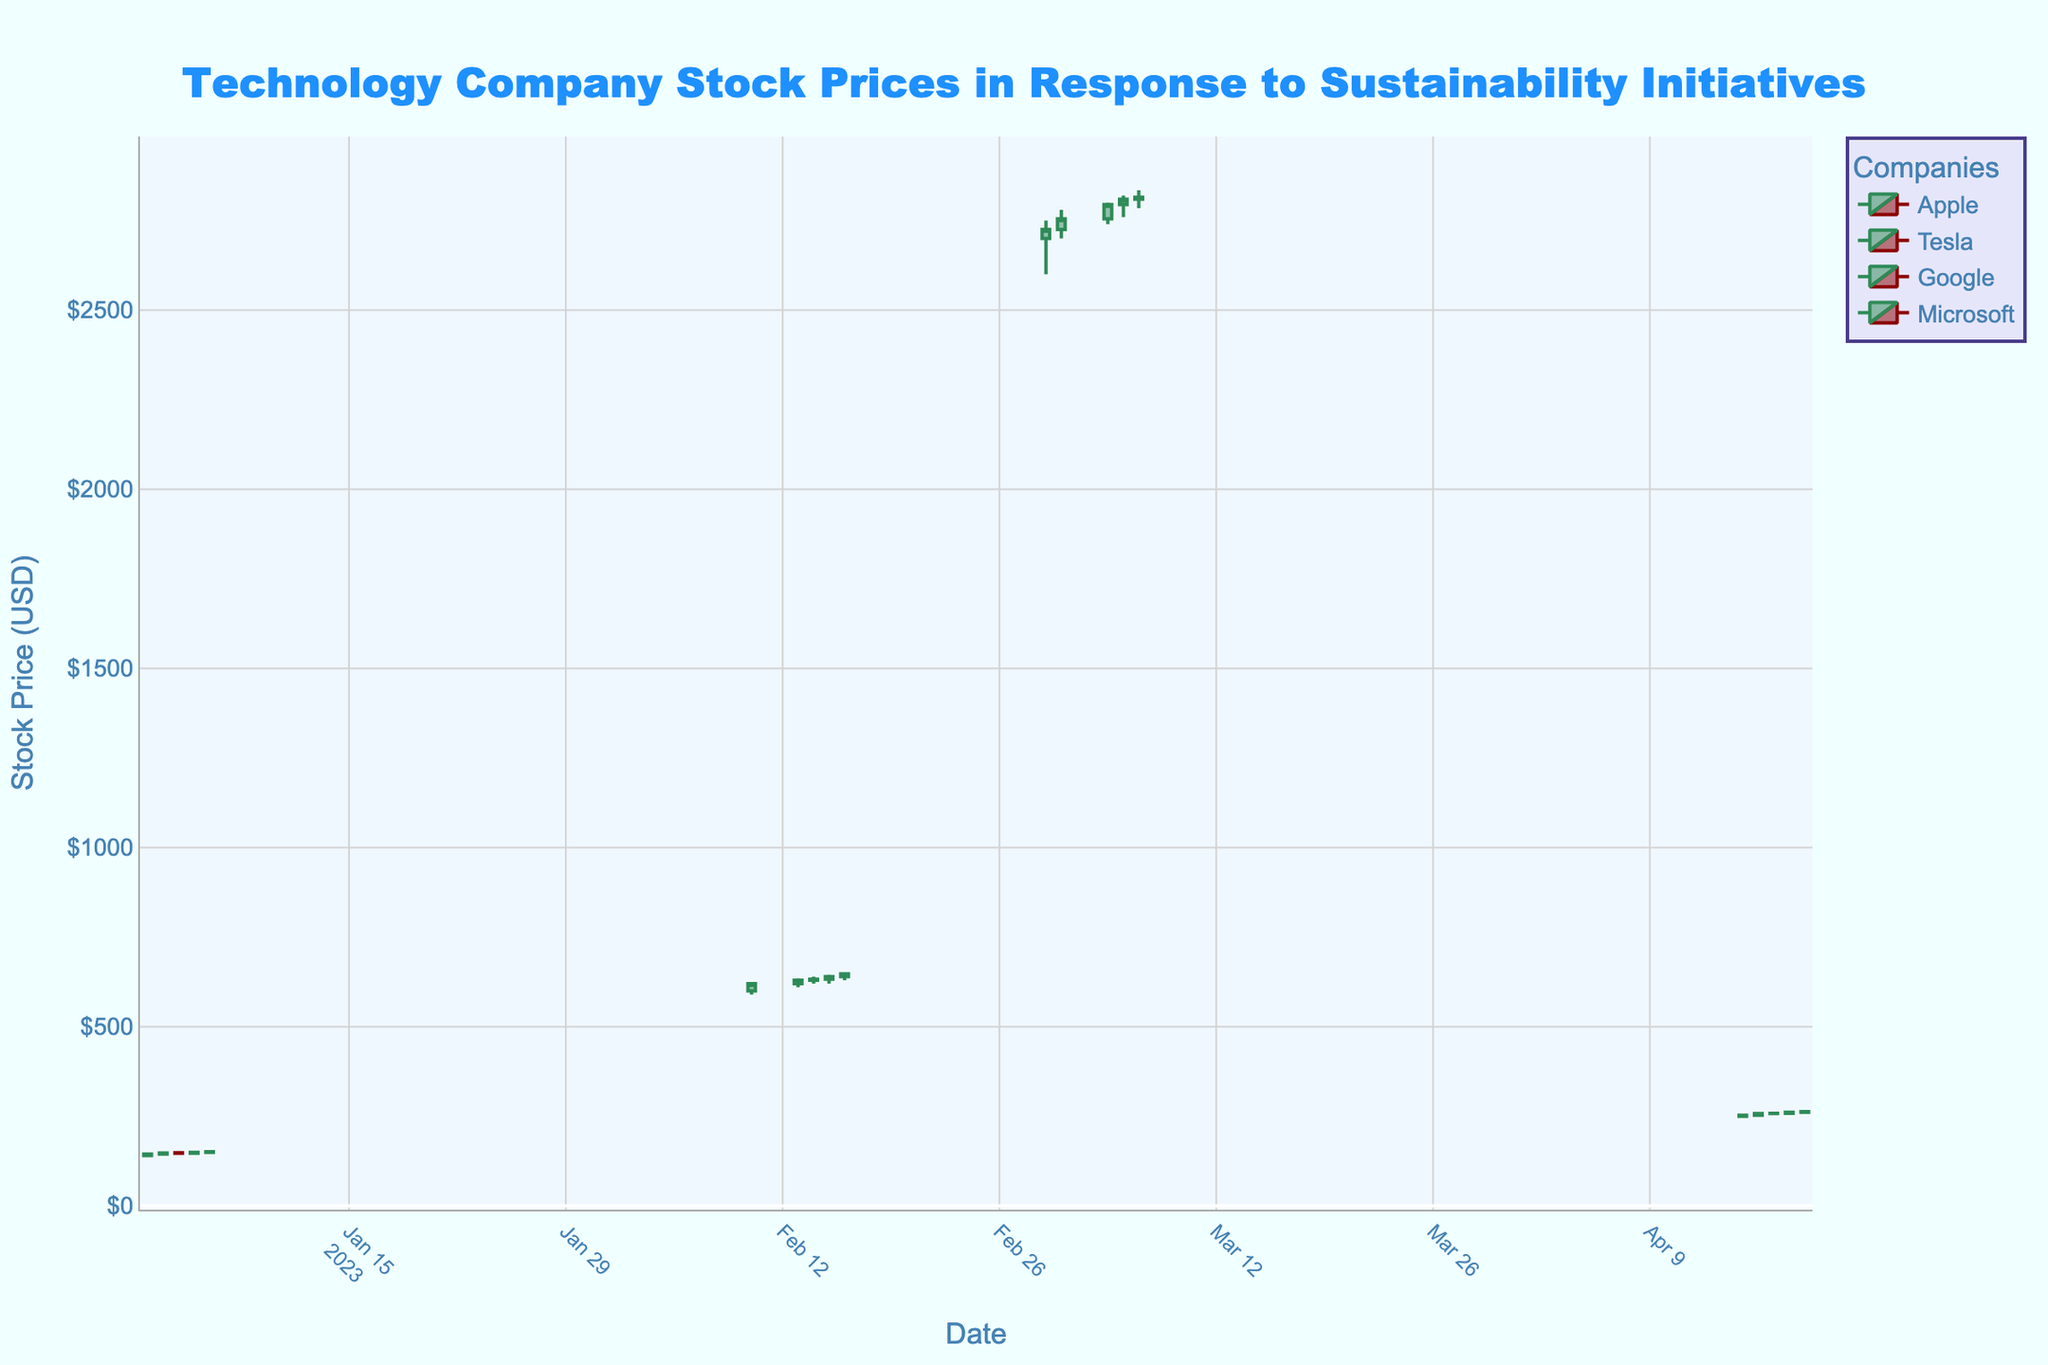What is the title of the figure? The title is displayed prominently at the top of the figure in a large font size and a blue color, making it easily noticeable.
Answer: Technology Company Stock Prices in Response to Sustainability Initiatives Which company had the highest stock price peak in the given data? To determine this, look for the highest point in the "High" markers across all candlestick plots. Tesla's highest peak was $650.00 on 2023-02-16.
Answer: Tesla On which date did Microsoft have the lowest stock price, and what was it? Look at the lowest points in the candlestick chart for Microsoft. The lowest was $245.00 on 2023-04-15.
Answer: 2023-04-15 and $245.00 How many data points are there for each company? Check the different candlestick sections for each company and count the number of dates involved. Each company has 5 data points.
Answer: 5 data points each What was the opening stock price for Apple on 2023-01-05? Identify the candlestick corresponding to 2023-01-05 for Apple and find the "Open" value. The opening price was $147.00.
Answer: $147.00 Which company's stock price increased the most in a single day and by how much? Identify the largest difference between "Low" and "High" values in a single candlestick. Tesla’s stock price increased by $35.00 on 2023-02-10, going from $590.00 to $625.00.
Answer: Tesla by $35.00 Compare the closing stock prices of Google on 2023-03-06 and 2023-03-07. Was there an increase or decrease, and by how much? Check the "Close" values for both dates and compute the difference. On 2023-03-06, it was $2810.00, and on 2023-03-07, it was $2815.00, an increase of $5.00.
Answer: Increase by $5.00 What was Tesla's average closing stock price over the given dates? Sum up all closing prices for Tesla and divide by the number of data points. ($620.00 + $630.00 + $632.50 + $640.00 + $647.50) / 5 = $634.00.
Answer: $634.00 When did Apple have its highest opening stock price and what was it? Look through the "Open" values for Apple across the dates and find the highest one. The highest opening price was $149.50 on 2023-01-06.
Answer: 2023-01-06 and $149.50 What is the general trend observed for Google's stock price from 2023-03-01 to 2023-03-07? Analyze the candlestick pattern over the dates 2023-03-01 to 2023-03-07 for Google. The trend is generally upward, moving from $2725.00 to $2815.00.
Answer: Upward Trend 